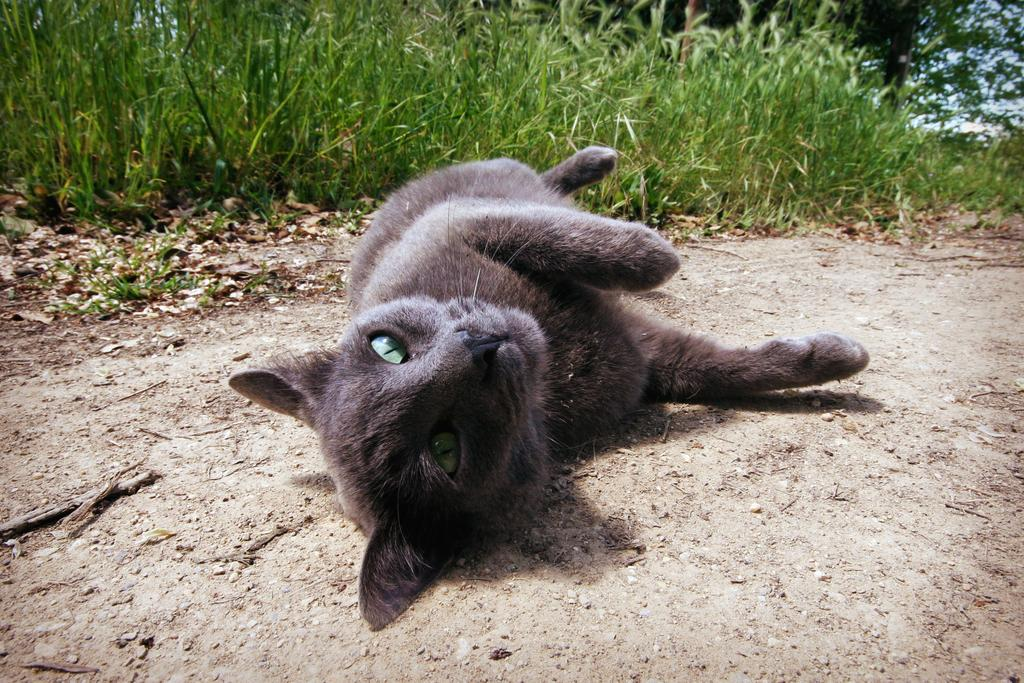What animal can be seen on the ground in the image? There is a cat on the ground in the image. What type of vegetation is present in the image? There are plants and trees in the image. What can be seen in the background of the image? The sky is visible in the image. What type of eye apparatus is being used by the cat in the image? There is no eye apparatus present in the image, as the cat does not appear to be using any device or equipment related to its eyes. 